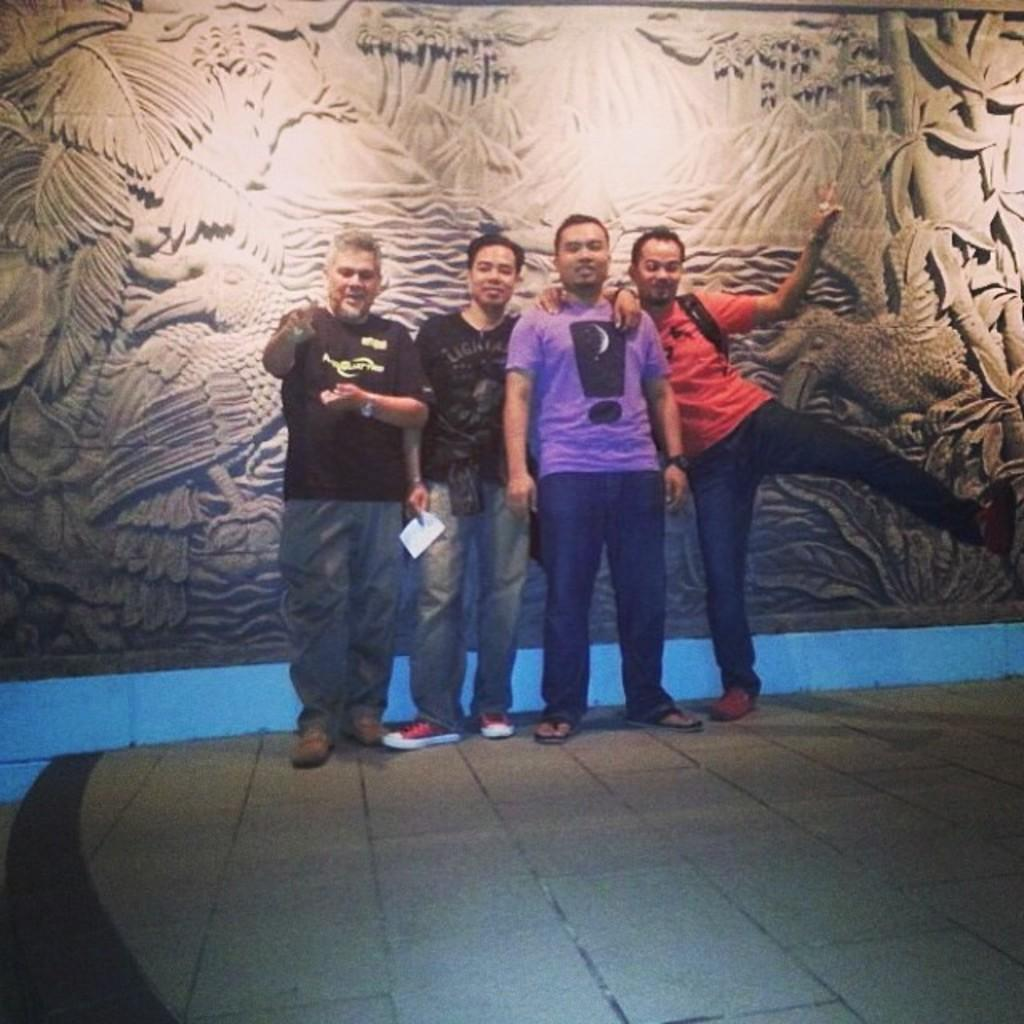What is the main subject of the image? The main subject of the image is a group of men standing in the center. What can be seen in the background of the image? There are sculptures on the wall in the background of the image. What is the primary element in the foreground of the image? The foreground of the image consists of the floor. How does the ship twist in the image? There is no ship present in the image, so it cannot twist. 